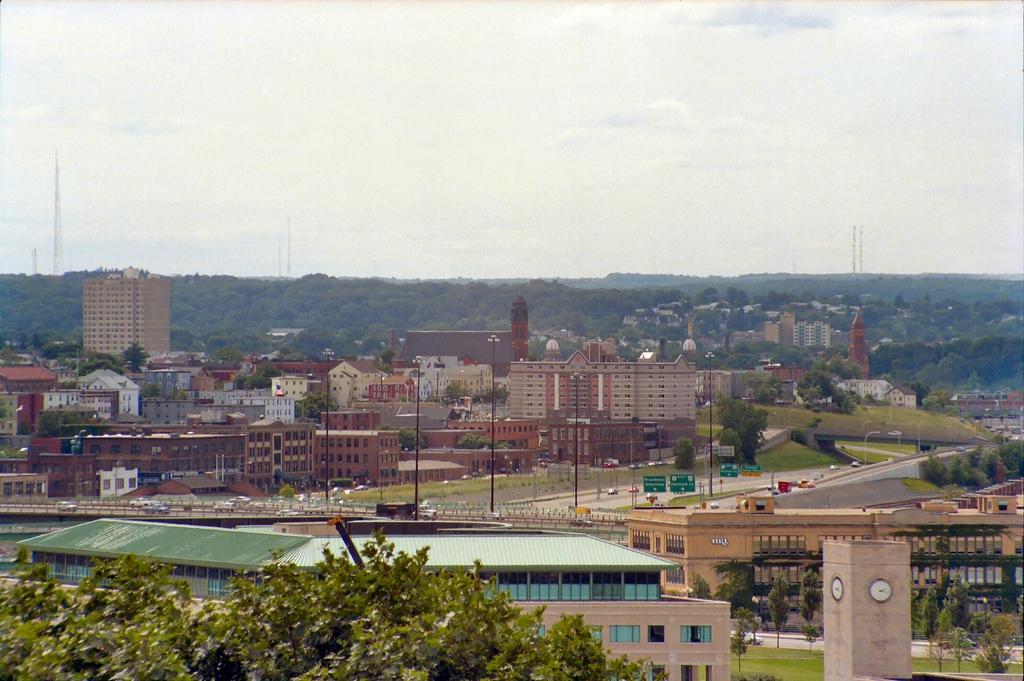How would you summarize this image in a sentence or two? In this picture I can see there are few buildings and there is a bridge here and there are vehicles moving on the bridge and there are trees, poles and the sky is clear. 